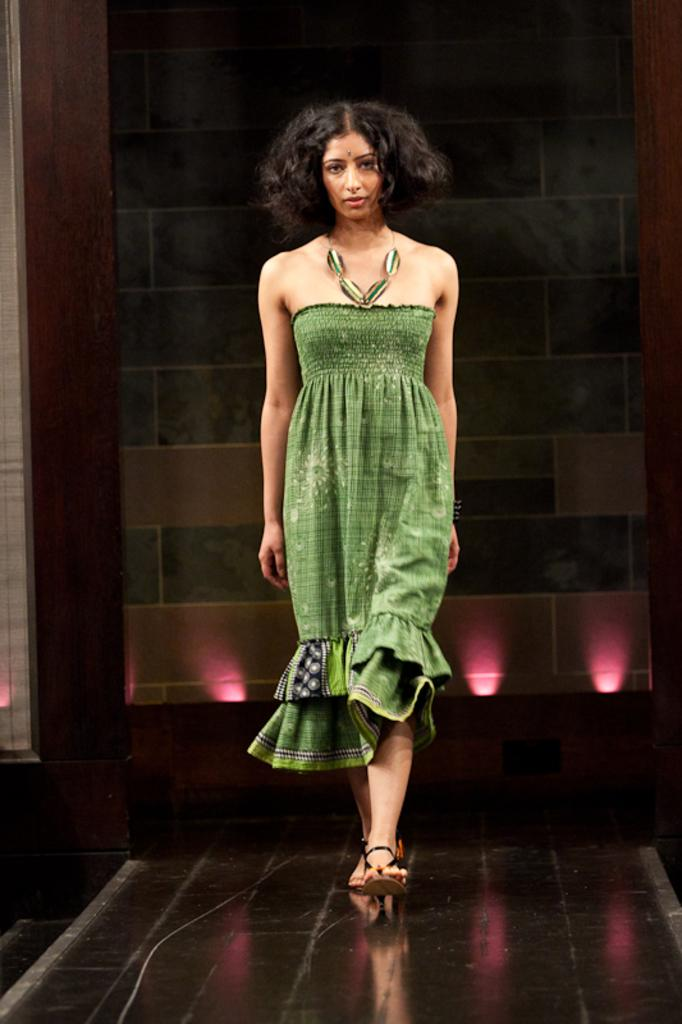What is the lady in the image doing? The lady is walking in the image. What can be seen in the background or surrounding the lady? There are lights visible in the image. What is the presence of a wall in the image? There is a wall in the image. What type of kite is the doctor exchanging with the lady in the image? There is no kite or doctor present in the image; it only features a lady walking and a wall in the background. 